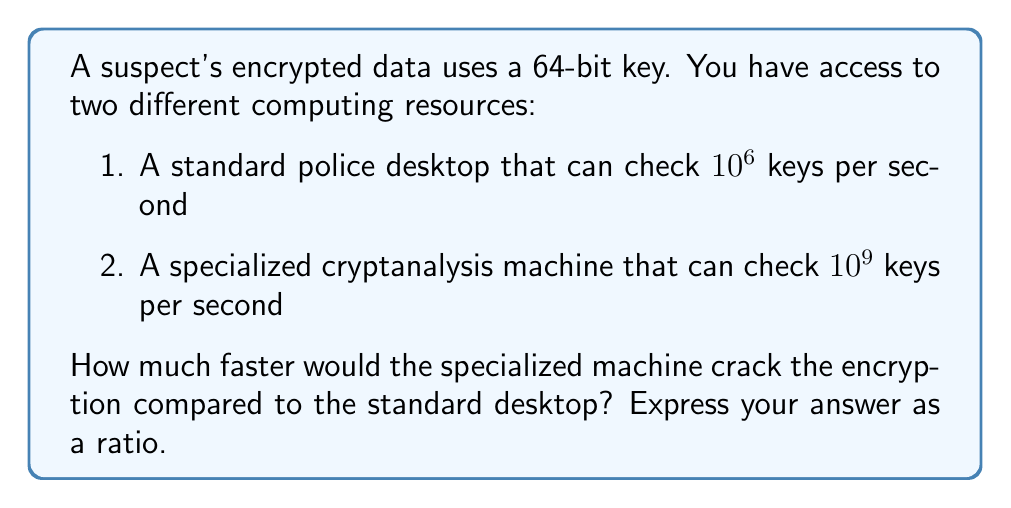Help me with this question. Let's approach this step-by-step:

1) First, we need to calculate the total number of possible keys:
   For a 64-bit key, there are $2^{64}$ possible combinations.

2) Now, let's calculate the time needed for each machine:

   For the standard desktop:
   $$T_d = \frac{2^{64}}{10^6} \text{ seconds}$$

   For the specialized machine:
   $$T_s = \frac{2^{64}}{10^9} \text{ seconds}$$

3) To find how much faster the specialized machine is, we need to divide $T_d$ by $T_s$:

   $$\frac{T_d}{T_s} = \frac{2^{64}/10^6}{2^{64}/10^9} = \frac{10^9}{10^6} = 10^3 = 1000$$

4) This means the specialized machine is 1000 times faster than the standard desktop.

5) We can express this as a ratio of 1000:1.
Answer: 1000:1 